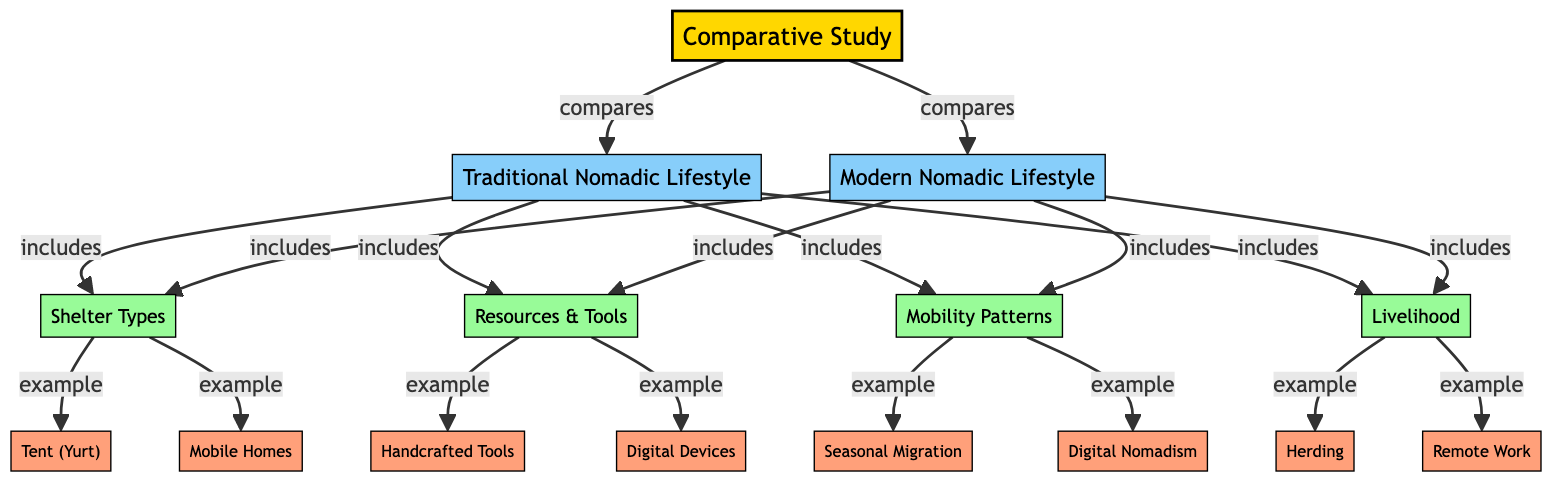What are the two main categories compared in the study? The diagram shows that the study compares "Traditional Nomadic Lifestyle" and "Modern Nomadic Lifestyle" as the two main categories.
Answer: Traditional Nomadic Lifestyle, Modern Nomadic Lifestyle What type of shelter is associated with the Traditional Nomadic Lifestyle? The diagram indicates that "Tent (Yurt)" is an example of shelter types associated with the Traditional Nomadic Lifestyle.
Answer: Tent (Yurt) How many examples of livelihood are presented in the diagram? The diagram lists two examples of livelihood: "Herding" and "Remote Work," thus presenting a total of two examples.
Answer: 2 What resource type is linked to the Modern Nomadic Lifestyle? The diagram shows "Digital Devices" as an example of resources and tools associated with the Modern Nomadic Lifestyle.
Answer: Digital Devices Which migration pattern is characteristic of the Traditional Nomadic Lifestyle? The diagram specifies "Seasonal Migration" as the example of mobility patterns associated with the Traditional Nomadic Lifestyle.
Answer: Seasonal Migration What example illustrates the resource tools in a Traditional Nomadic Lifestyle? The diagram lists "Handcrafted Tools" as the example of resources and tools related to the Traditional Nomadic Lifestyle.
Answer: Handcrafted Tools What is the relationship between "Resources & Tools" and "Shelter Types"? The diagram indicates that both "Traditional Nomadic Lifestyle" and "Modern Nomadic Lifestyle" include "Resources & Tools" and "Shelter Types," suggesting they share this aspect.
Answer: They share similar aspects What mobility pattern is unique to the Modern Nomadic Lifestyle? The diagram presents "Digital Nomadism" as a unique mobility pattern associated with the Modern Nomadic Lifestyle.
Answer: Digital Nomadism What is an example of a livelihood associated with the Modern Nomadic Lifestyle? The diagram provides "Remote Work" as an example of livelihood associated with the Modern Nomadic Lifestyle.
Answer: Remote Work 